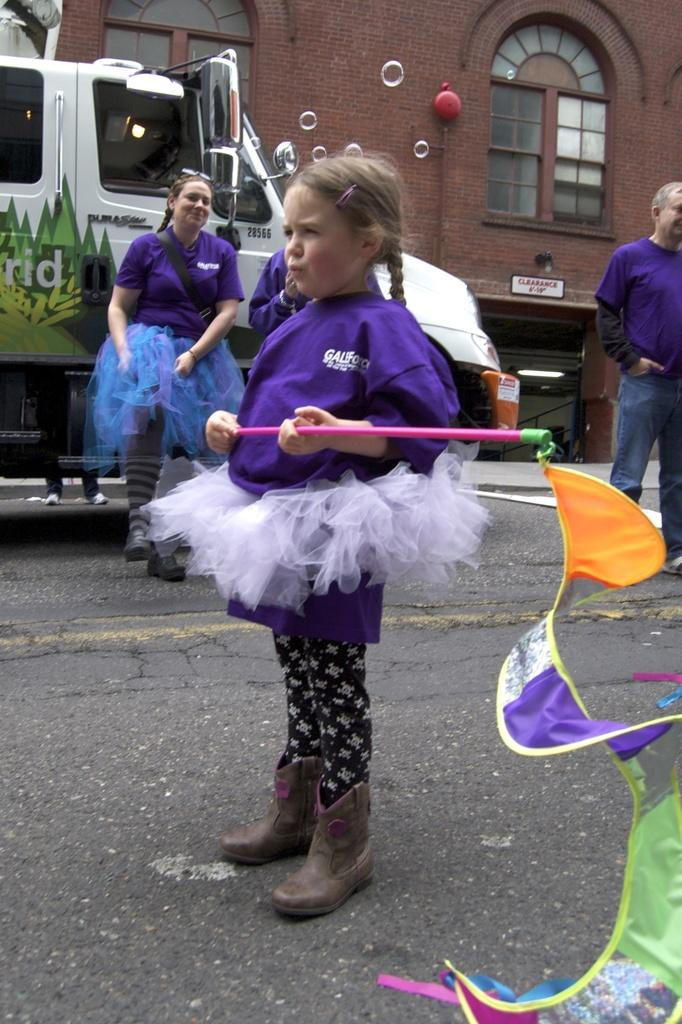What is the main subject in the foreground of the image? There is a small girl in the foreground of the image. What is the girl holding in the image? The girl is holding a colorful flag. What can be seen in the background of the image? There are people, a vehicle, a building, windows, and a small board in the background of the image. What type of bone can be seen in the girl's hand in the image? There is no bone present in the image; the girl is holding a colorful flag. 